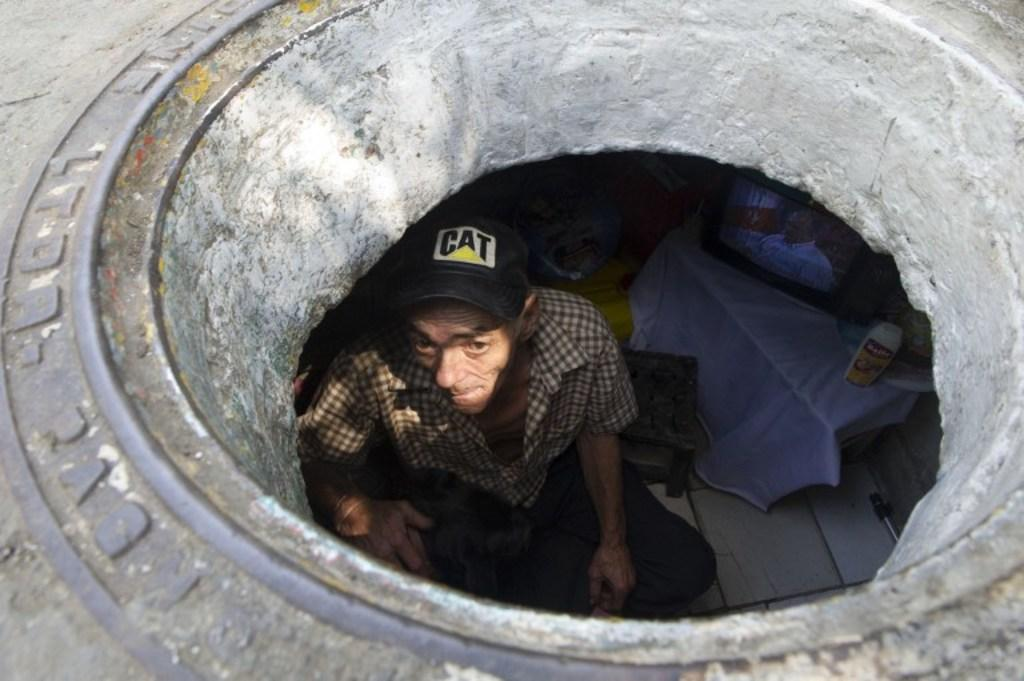What is the man in the image doing? The man is sitting in the image. Can you describe the man's attire? The man is wearing a cap. What is located on the right side of the image? There is a table on the right side of the image. What is on the table? There is a television and a cloth on the table. What type of object might be used for covering or cleaning in the image? The cloth on the table might be used for covering or cleaning. What type of structure can be seen in the image? It appears to be a manhole in the image. What type of rabbit can be seen hopping on the man's neck in the image? There is no rabbit present in the image, and the man's neck is not visible. What grade does the man receive for his performance in the image? There is no indication of a performance or grading system in the image. 